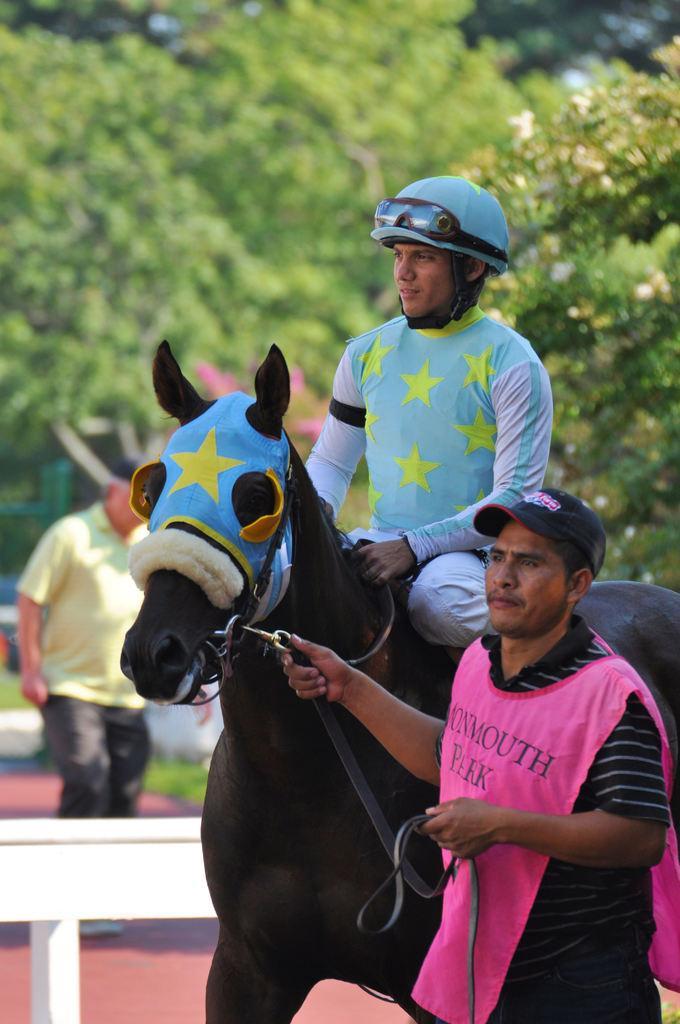Describe this image in one or two sentences. Here is man standing and holding the horse,and the other man is sitting and riding the horse. At background I can see a man standing and there are trees. 